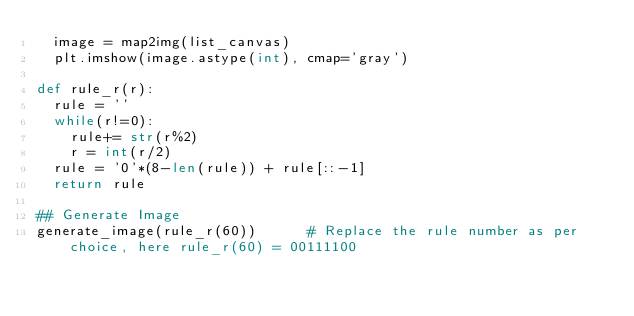Convert code to text. <code><loc_0><loc_0><loc_500><loc_500><_Python_>  image = map2img(list_canvas)
  plt.imshow(image.astype(int), cmap='gray')

def rule_r(r):
  rule = ''
  while(r!=0):
    rule+= str(r%2)
    r = int(r/2)
  rule = '0'*(8-len(rule)) + rule[::-1]
  return rule

## Generate Image
generate_image(rule_r(60))		# Replace the rule number as per choice, here rule_r(60) = 00111100  


</code> 